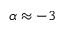Convert formula to latex. <formula><loc_0><loc_0><loc_500><loc_500>\alpha \approx - 3</formula> 